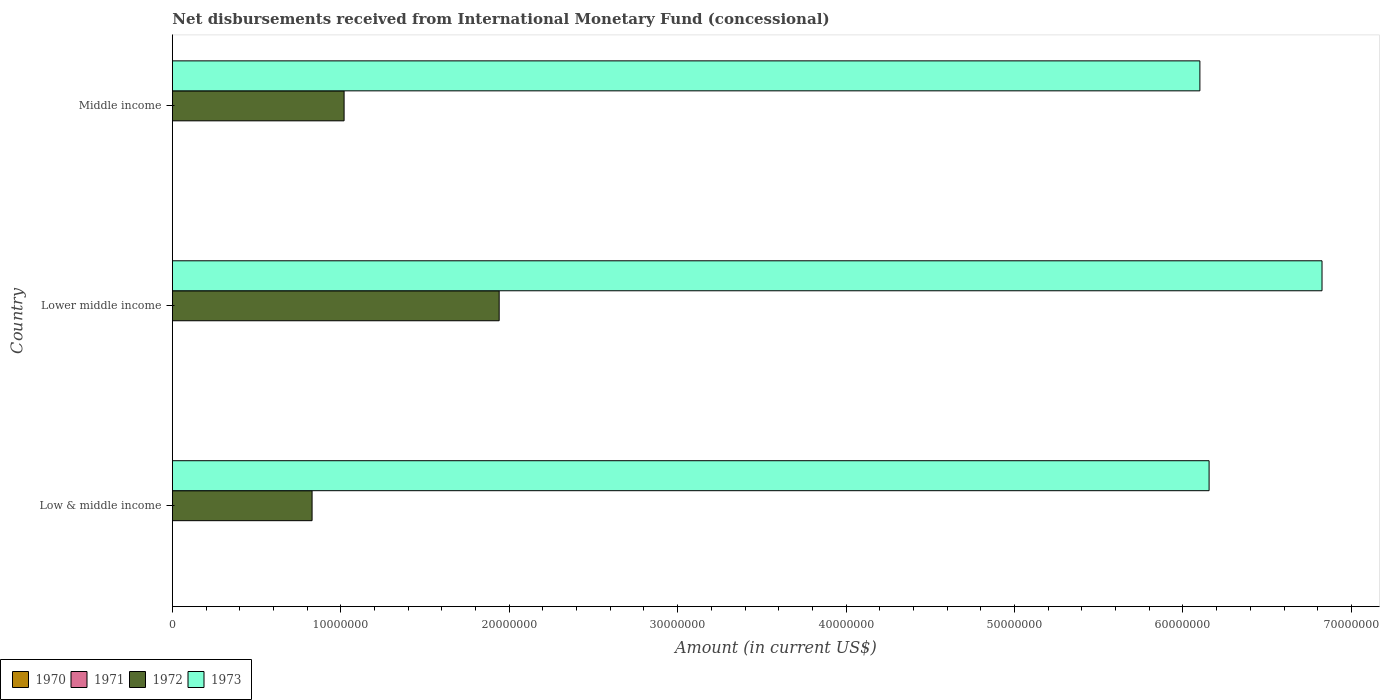How many different coloured bars are there?
Your answer should be very brief. 2. Are the number of bars per tick equal to the number of legend labels?
Give a very brief answer. No. Are the number of bars on each tick of the Y-axis equal?
Your response must be concise. Yes. How many bars are there on the 2nd tick from the bottom?
Ensure brevity in your answer.  2. What is the amount of disbursements received from International Monetary Fund in 1973 in Lower middle income?
Your response must be concise. 6.83e+07. Across all countries, what is the maximum amount of disbursements received from International Monetary Fund in 1973?
Your response must be concise. 6.83e+07. Across all countries, what is the minimum amount of disbursements received from International Monetary Fund in 1972?
Ensure brevity in your answer.  8.30e+06. In which country was the amount of disbursements received from International Monetary Fund in 1972 maximum?
Provide a succinct answer. Lower middle income. What is the total amount of disbursements received from International Monetary Fund in 1970 in the graph?
Your response must be concise. 0. What is the difference between the amount of disbursements received from International Monetary Fund in 1973 in Low & middle income and that in Lower middle income?
Your answer should be very brief. -6.70e+06. What is the difference between the amount of disbursements received from International Monetary Fund in 1972 in Middle income and the amount of disbursements received from International Monetary Fund in 1973 in Low & middle income?
Give a very brief answer. -5.14e+07. What is the average amount of disbursements received from International Monetary Fund in 1973 per country?
Make the answer very short. 6.36e+07. What is the difference between the amount of disbursements received from International Monetary Fund in 1973 and amount of disbursements received from International Monetary Fund in 1972 in Lower middle income?
Ensure brevity in your answer.  4.89e+07. In how many countries, is the amount of disbursements received from International Monetary Fund in 1971 greater than 26000000 US$?
Make the answer very short. 0. What is the ratio of the amount of disbursements received from International Monetary Fund in 1972 in Lower middle income to that in Middle income?
Give a very brief answer. 1.9. What is the difference between the highest and the second highest amount of disbursements received from International Monetary Fund in 1972?
Your answer should be compact. 9.21e+06. What is the difference between the highest and the lowest amount of disbursements received from International Monetary Fund in 1973?
Make the answer very short. 7.25e+06. Is it the case that in every country, the sum of the amount of disbursements received from International Monetary Fund in 1972 and amount of disbursements received from International Monetary Fund in 1970 is greater than the sum of amount of disbursements received from International Monetary Fund in 1971 and amount of disbursements received from International Monetary Fund in 1973?
Ensure brevity in your answer.  No. What is the difference between two consecutive major ticks on the X-axis?
Give a very brief answer. 1.00e+07. Does the graph contain any zero values?
Your answer should be very brief. Yes. Does the graph contain grids?
Offer a terse response. No. Where does the legend appear in the graph?
Give a very brief answer. Bottom left. How are the legend labels stacked?
Your response must be concise. Horizontal. What is the title of the graph?
Your answer should be compact. Net disbursements received from International Monetary Fund (concessional). Does "1996" appear as one of the legend labels in the graph?
Give a very brief answer. No. What is the label or title of the X-axis?
Make the answer very short. Amount (in current US$). What is the Amount (in current US$) in 1970 in Low & middle income?
Your answer should be compact. 0. What is the Amount (in current US$) of 1971 in Low & middle income?
Give a very brief answer. 0. What is the Amount (in current US$) of 1972 in Low & middle income?
Provide a short and direct response. 8.30e+06. What is the Amount (in current US$) in 1973 in Low & middle income?
Make the answer very short. 6.16e+07. What is the Amount (in current US$) in 1971 in Lower middle income?
Ensure brevity in your answer.  0. What is the Amount (in current US$) of 1972 in Lower middle income?
Your answer should be compact. 1.94e+07. What is the Amount (in current US$) in 1973 in Lower middle income?
Keep it short and to the point. 6.83e+07. What is the Amount (in current US$) in 1971 in Middle income?
Your answer should be compact. 0. What is the Amount (in current US$) of 1972 in Middle income?
Your answer should be very brief. 1.02e+07. What is the Amount (in current US$) of 1973 in Middle income?
Your answer should be very brief. 6.10e+07. Across all countries, what is the maximum Amount (in current US$) in 1972?
Your answer should be very brief. 1.94e+07. Across all countries, what is the maximum Amount (in current US$) in 1973?
Ensure brevity in your answer.  6.83e+07. Across all countries, what is the minimum Amount (in current US$) in 1972?
Make the answer very short. 8.30e+06. Across all countries, what is the minimum Amount (in current US$) in 1973?
Provide a succinct answer. 6.10e+07. What is the total Amount (in current US$) of 1972 in the graph?
Ensure brevity in your answer.  3.79e+07. What is the total Amount (in current US$) in 1973 in the graph?
Make the answer very short. 1.91e+08. What is the difference between the Amount (in current US$) in 1972 in Low & middle income and that in Lower middle income?
Your answer should be compact. -1.11e+07. What is the difference between the Amount (in current US$) of 1973 in Low & middle income and that in Lower middle income?
Offer a terse response. -6.70e+06. What is the difference between the Amount (in current US$) in 1972 in Low & middle income and that in Middle income?
Make the answer very short. -1.90e+06. What is the difference between the Amount (in current US$) of 1973 in Low & middle income and that in Middle income?
Your answer should be compact. 5.46e+05. What is the difference between the Amount (in current US$) in 1972 in Lower middle income and that in Middle income?
Your answer should be compact. 9.21e+06. What is the difference between the Amount (in current US$) of 1973 in Lower middle income and that in Middle income?
Provide a short and direct response. 7.25e+06. What is the difference between the Amount (in current US$) in 1972 in Low & middle income and the Amount (in current US$) in 1973 in Lower middle income?
Give a very brief answer. -6.00e+07. What is the difference between the Amount (in current US$) of 1972 in Low & middle income and the Amount (in current US$) of 1973 in Middle income?
Your response must be concise. -5.27e+07. What is the difference between the Amount (in current US$) in 1972 in Lower middle income and the Amount (in current US$) in 1973 in Middle income?
Offer a very short reply. -4.16e+07. What is the average Amount (in current US$) of 1972 per country?
Make the answer very short. 1.26e+07. What is the average Amount (in current US$) of 1973 per country?
Provide a succinct answer. 6.36e+07. What is the difference between the Amount (in current US$) of 1972 and Amount (in current US$) of 1973 in Low & middle income?
Keep it short and to the point. -5.33e+07. What is the difference between the Amount (in current US$) in 1972 and Amount (in current US$) in 1973 in Lower middle income?
Provide a succinct answer. -4.89e+07. What is the difference between the Amount (in current US$) in 1972 and Amount (in current US$) in 1973 in Middle income?
Your answer should be very brief. -5.08e+07. What is the ratio of the Amount (in current US$) in 1972 in Low & middle income to that in Lower middle income?
Provide a short and direct response. 0.43. What is the ratio of the Amount (in current US$) of 1973 in Low & middle income to that in Lower middle income?
Provide a short and direct response. 0.9. What is the ratio of the Amount (in current US$) of 1972 in Low & middle income to that in Middle income?
Ensure brevity in your answer.  0.81. What is the ratio of the Amount (in current US$) in 1972 in Lower middle income to that in Middle income?
Provide a short and direct response. 1.9. What is the ratio of the Amount (in current US$) in 1973 in Lower middle income to that in Middle income?
Your answer should be very brief. 1.12. What is the difference between the highest and the second highest Amount (in current US$) in 1972?
Ensure brevity in your answer.  9.21e+06. What is the difference between the highest and the second highest Amount (in current US$) of 1973?
Your answer should be compact. 6.70e+06. What is the difference between the highest and the lowest Amount (in current US$) in 1972?
Keep it short and to the point. 1.11e+07. What is the difference between the highest and the lowest Amount (in current US$) of 1973?
Provide a short and direct response. 7.25e+06. 